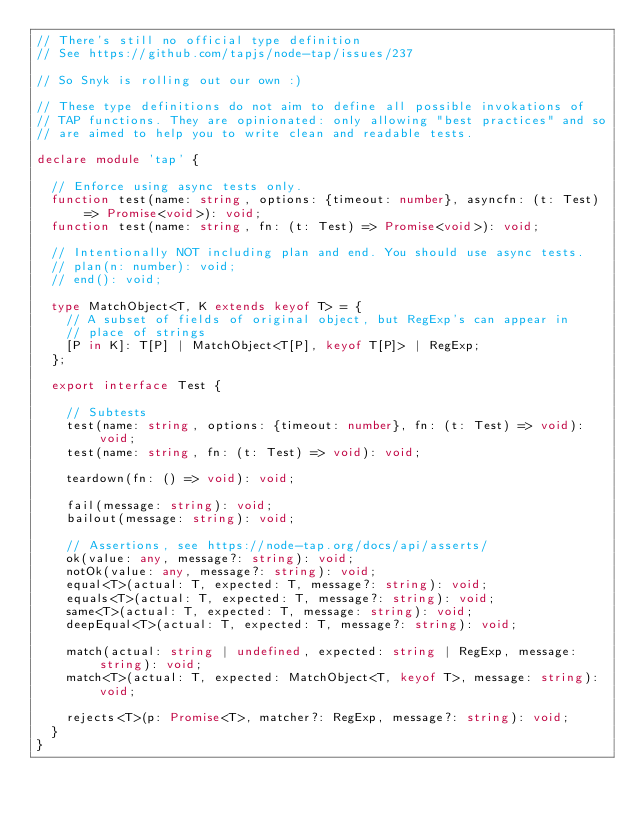Convert code to text. <code><loc_0><loc_0><loc_500><loc_500><_TypeScript_>// There's still no official type definition
// See https://github.com/tapjs/node-tap/issues/237

// So Snyk is rolling out our own :)

// These type definitions do not aim to define all possible invokations of
// TAP functions. They are opinionated: only allowing "best practices" and so
// are aimed to help you to write clean and readable tests.

declare module 'tap' {

  // Enforce using async tests only.
  function test(name: string, options: {timeout: number}, asyncfn: (t: Test) => Promise<void>): void;
  function test(name: string, fn: (t: Test) => Promise<void>): void;

  // Intentionally NOT including plan and end. You should use async tests.
  // plan(n: number): void;
  // end(): void;

  type MatchObject<T, K extends keyof T> = {
    // A subset of fields of original object, but RegExp's can appear in
    // place of strings
    [P in K]: T[P] | MatchObject<T[P], keyof T[P]> | RegExp;
  };

  export interface Test {

    // Subtests
    test(name: string, options: {timeout: number}, fn: (t: Test) => void): void;
    test(name: string, fn: (t: Test) => void): void;

    teardown(fn: () => void): void;

    fail(message: string): void;
    bailout(message: string): void;

    // Assertions, see https://node-tap.org/docs/api/asserts/
    ok(value: any, message?: string): void;
    notOk(value: any, message?: string): void;
    equal<T>(actual: T, expected: T, message?: string): void;
    equals<T>(actual: T, expected: T, message?: string): void;
    same<T>(actual: T, expected: T, message: string): void;
    deepEqual<T>(actual: T, expected: T, message?: string): void;

    match(actual: string | undefined, expected: string | RegExp, message: string): void;
    match<T>(actual: T, expected: MatchObject<T, keyof T>, message: string): void;

    rejects<T>(p: Promise<T>, matcher?: RegExp, message?: string): void;
  }
}
</code> 